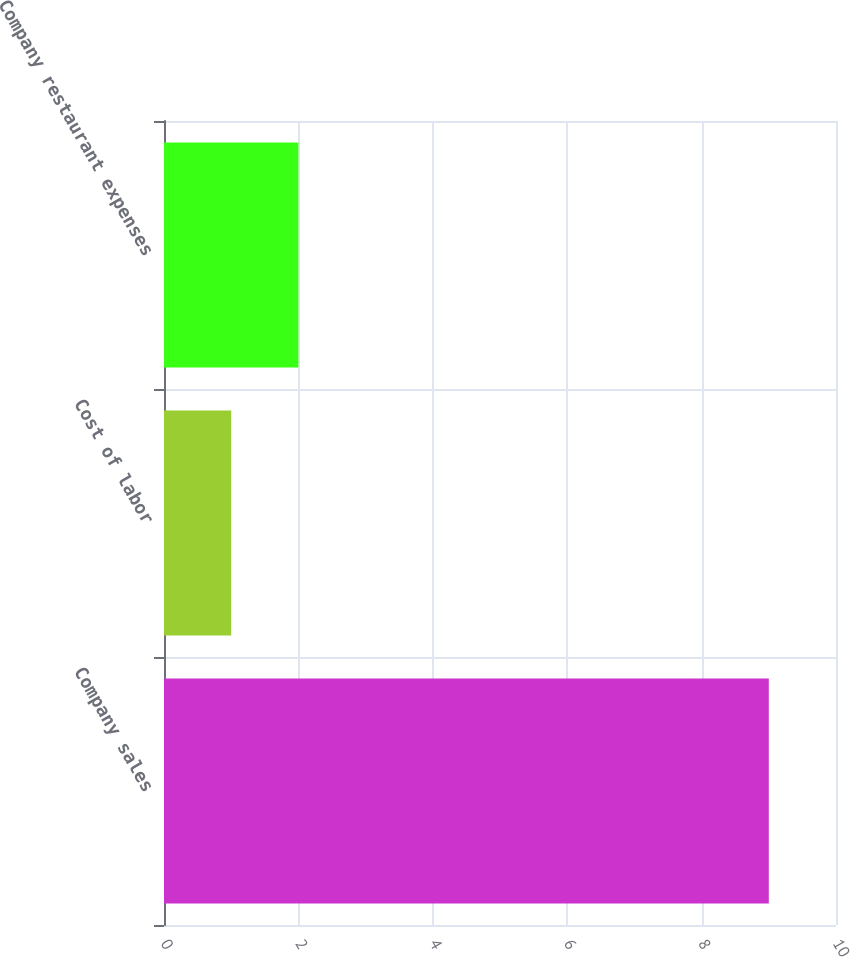<chart> <loc_0><loc_0><loc_500><loc_500><bar_chart><fcel>Company sales<fcel>Cost of labor<fcel>Company restaurant expenses<nl><fcel>9<fcel>1<fcel>2<nl></chart> 